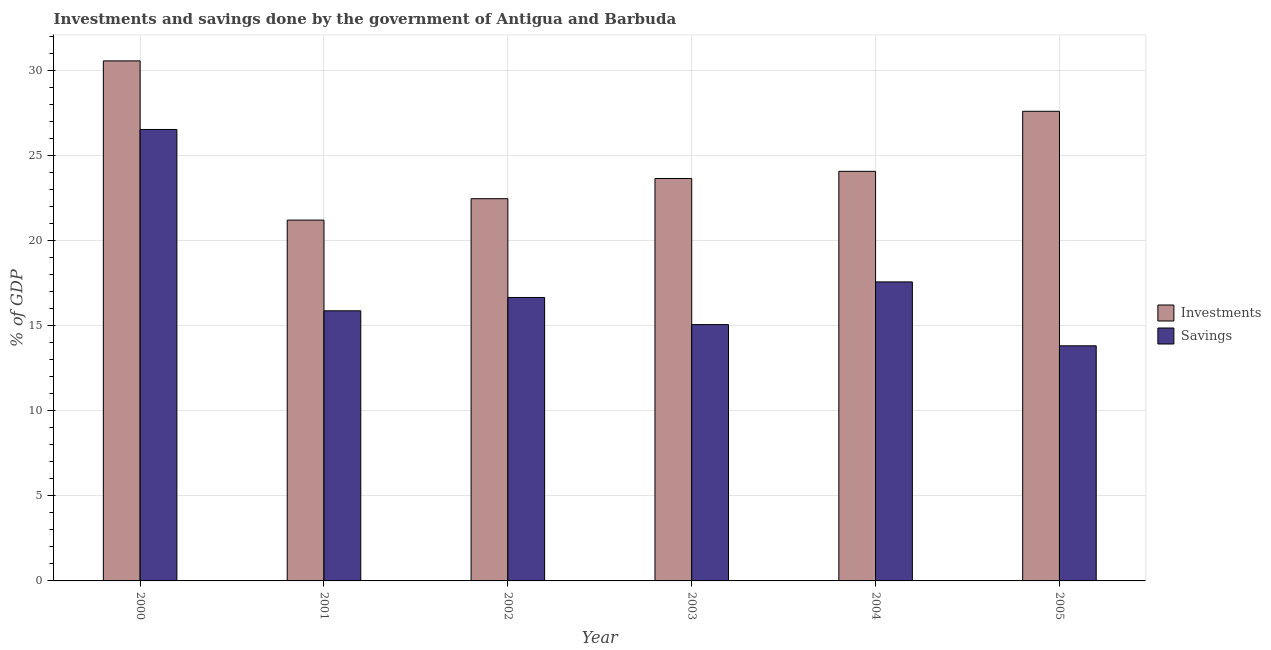Are the number of bars per tick equal to the number of legend labels?
Provide a short and direct response. Yes. Are the number of bars on each tick of the X-axis equal?
Ensure brevity in your answer.  Yes. What is the label of the 2nd group of bars from the left?
Ensure brevity in your answer.  2001. In how many cases, is the number of bars for a given year not equal to the number of legend labels?
Keep it short and to the point. 0. What is the savings of government in 2003?
Offer a very short reply. 15.06. Across all years, what is the maximum savings of government?
Offer a terse response. 26.53. Across all years, what is the minimum investments of government?
Provide a short and direct response. 21.2. In which year was the investments of government maximum?
Provide a short and direct response. 2000. In which year was the investments of government minimum?
Your answer should be compact. 2001. What is the total savings of government in the graph?
Your answer should be compact. 105.51. What is the difference between the investments of government in 2001 and that in 2002?
Your answer should be very brief. -1.26. What is the difference between the savings of government in 2005 and the investments of government in 2003?
Offer a terse response. -1.25. What is the average investments of government per year?
Offer a terse response. 24.92. In the year 2005, what is the difference between the savings of government and investments of government?
Offer a terse response. 0. In how many years, is the savings of government greater than 9 %?
Offer a terse response. 6. What is the ratio of the investments of government in 2002 to that in 2004?
Give a very brief answer. 0.93. Is the savings of government in 2001 less than that in 2003?
Provide a short and direct response. No. What is the difference between the highest and the second highest savings of government?
Provide a short and direct response. 8.96. What is the difference between the highest and the lowest investments of government?
Your answer should be compact. 9.36. What does the 1st bar from the left in 2001 represents?
Provide a short and direct response. Investments. What does the 2nd bar from the right in 2002 represents?
Your answer should be very brief. Investments. Are all the bars in the graph horizontal?
Provide a short and direct response. No. How many years are there in the graph?
Provide a short and direct response. 6. What is the difference between two consecutive major ticks on the Y-axis?
Make the answer very short. 5. Are the values on the major ticks of Y-axis written in scientific E-notation?
Offer a very short reply. No. Does the graph contain grids?
Keep it short and to the point. Yes. Where does the legend appear in the graph?
Offer a very short reply. Center right. What is the title of the graph?
Give a very brief answer. Investments and savings done by the government of Antigua and Barbuda. Does "Official aid received" appear as one of the legend labels in the graph?
Give a very brief answer. No. What is the label or title of the X-axis?
Provide a succinct answer. Year. What is the label or title of the Y-axis?
Ensure brevity in your answer.  % of GDP. What is the % of GDP in Investments in 2000?
Make the answer very short. 30.56. What is the % of GDP of Savings in 2000?
Your answer should be very brief. 26.53. What is the % of GDP of Investments in 2001?
Your answer should be compact. 21.2. What is the % of GDP in Savings in 2001?
Offer a terse response. 15.87. What is the % of GDP in Investments in 2002?
Offer a very short reply. 22.46. What is the % of GDP in Savings in 2002?
Your response must be concise. 16.66. What is the % of GDP in Investments in 2003?
Your answer should be compact. 23.65. What is the % of GDP of Savings in 2003?
Give a very brief answer. 15.06. What is the % of GDP of Investments in 2004?
Provide a succinct answer. 24.07. What is the % of GDP in Savings in 2004?
Keep it short and to the point. 17.57. What is the % of GDP in Investments in 2005?
Offer a very short reply. 27.6. What is the % of GDP of Savings in 2005?
Provide a succinct answer. 13.82. Across all years, what is the maximum % of GDP of Investments?
Provide a succinct answer. 30.56. Across all years, what is the maximum % of GDP of Savings?
Provide a short and direct response. 26.53. Across all years, what is the minimum % of GDP of Investments?
Your answer should be very brief. 21.2. Across all years, what is the minimum % of GDP in Savings?
Provide a short and direct response. 13.82. What is the total % of GDP of Investments in the graph?
Provide a short and direct response. 149.53. What is the total % of GDP in Savings in the graph?
Keep it short and to the point. 105.51. What is the difference between the % of GDP in Investments in 2000 and that in 2001?
Give a very brief answer. 9.36. What is the difference between the % of GDP of Savings in 2000 and that in 2001?
Provide a short and direct response. 10.65. What is the difference between the % of GDP in Investments in 2000 and that in 2002?
Provide a short and direct response. 8.1. What is the difference between the % of GDP of Savings in 2000 and that in 2002?
Your answer should be compact. 9.87. What is the difference between the % of GDP of Investments in 2000 and that in 2003?
Offer a terse response. 6.91. What is the difference between the % of GDP of Savings in 2000 and that in 2003?
Your answer should be compact. 11.47. What is the difference between the % of GDP of Investments in 2000 and that in 2004?
Provide a succinct answer. 6.49. What is the difference between the % of GDP in Savings in 2000 and that in 2004?
Give a very brief answer. 8.96. What is the difference between the % of GDP in Investments in 2000 and that in 2005?
Offer a terse response. 2.96. What is the difference between the % of GDP in Savings in 2000 and that in 2005?
Keep it short and to the point. 12.71. What is the difference between the % of GDP of Investments in 2001 and that in 2002?
Your response must be concise. -1.26. What is the difference between the % of GDP in Savings in 2001 and that in 2002?
Keep it short and to the point. -0.78. What is the difference between the % of GDP of Investments in 2001 and that in 2003?
Make the answer very short. -2.44. What is the difference between the % of GDP in Savings in 2001 and that in 2003?
Make the answer very short. 0.81. What is the difference between the % of GDP in Investments in 2001 and that in 2004?
Provide a succinct answer. -2.87. What is the difference between the % of GDP in Savings in 2001 and that in 2004?
Make the answer very short. -1.7. What is the difference between the % of GDP of Investments in 2001 and that in 2005?
Your answer should be compact. -6.39. What is the difference between the % of GDP of Savings in 2001 and that in 2005?
Offer a very short reply. 2.06. What is the difference between the % of GDP of Investments in 2002 and that in 2003?
Provide a short and direct response. -1.19. What is the difference between the % of GDP in Savings in 2002 and that in 2003?
Give a very brief answer. 1.59. What is the difference between the % of GDP of Investments in 2002 and that in 2004?
Your answer should be compact. -1.61. What is the difference between the % of GDP of Savings in 2002 and that in 2004?
Your answer should be compact. -0.92. What is the difference between the % of GDP in Investments in 2002 and that in 2005?
Your response must be concise. -5.14. What is the difference between the % of GDP in Savings in 2002 and that in 2005?
Offer a terse response. 2.84. What is the difference between the % of GDP in Investments in 2003 and that in 2004?
Give a very brief answer. -0.42. What is the difference between the % of GDP in Savings in 2003 and that in 2004?
Give a very brief answer. -2.51. What is the difference between the % of GDP of Investments in 2003 and that in 2005?
Offer a terse response. -3.95. What is the difference between the % of GDP in Savings in 2003 and that in 2005?
Offer a very short reply. 1.25. What is the difference between the % of GDP of Investments in 2004 and that in 2005?
Offer a terse response. -3.53. What is the difference between the % of GDP of Savings in 2004 and that in 2005?
Offer a very short reply. 3.76. What is the difference between the % of GDP in Investments in 2000 and the % of GDP in Savings in 2001?
Ensure brevity in your answer.  14.69. What is the difference between the % of GDP in Investments in 2000 and the % of GDP in Savings in 2002?
Give a very brief answer. 13.9. What is the difference between the % of GDP of Investments in 2000 and the % of GDP of Savings in 2003?
Offer a very short reply. 15.5. What is the difference between the % of GDP of Investments in 2000 and the % of GDP of Savings in 2004?
Your response must be concise. 12.99. What is the difference between the % of GDP of Investments in 2000 and the % of GDP of Savings in 2005?
Make the answer very short. 16.74. What is the difference between the % of GDP of Investments in 2001 and the % of GDP of Savings in 2002?
Give a very brief answer. 4.55. What is the difference between the % of GDP in Investments in 2001 and the % of GDP in Savings in 2003?
Your response must be concise. 6.14. What is the difference between the % of GDP in Investments in 2001 and the % of GDP in Savings in 2004?
Give a very brief answer. 3.63. What is the difference between the % of GDP of Investments in 2001 and the % of GDP of Savings in 2005?
Offer a terse response. 7.39. What is the difference between the % of GDP of Investments in 2002 and the % of GDP of Savings in 2003?
Make the answer very short. 7.4. What is the difference between the % of GDP in Investments in 2002 and the % of GDP in Savings in 2004?
Offer a terse response. 4.89. What is the difference between the % of GDP in Investments in 2002 and the % of GDP in Savings in 2005?
Offer a very short reply. 8.64. What is the difference between the % of GDP in Investments in 2003 and the % of GDP in Savings in 2004?
Your answer should be compact. 6.08. What is the difference between the % of GDP in Investments in 2003 and the % of GDP in Savings in 2005?
Offer a very short reply. 9.83. What is the difference between the % of GDP of Investments in 2004 and the % of GDP of Savings in 2005?
Your answer should be compact. 10.25. What is the average % of GDP in Investments per year?
Give a very brief answer. 24.92. What is the average % of GDP of Savings per year?
Ensure brevity in your answer.  17.58. In the year 2000, what is the difference between the % of GDP in Investments and % of GDP in Savings?
Give a very brief answer. 4.03. In the year 2001, what is the difference between the % of GDP of Investments and % of GDP of Savings?
Ensure brevity in your answer.  5.33. In the year 2002, what is the difference between the % of GDP in Investments and % of GDP in Savings?
Provide a succinct answer. 5.8. In the year 2003, what is the difference between the % of GDP of Investments and % of GDP of Savings?
Offer a terse response. 8.58. In the year 2004, what is the difference between the % of GDP in Investments and % of GDP in Savings?
Provide a succinct answer. 6.5. In the year 2005, what is the difference between the % of GDP in Investments and % of GDP in Savings?
Offer a very short reply. 13.78. What is the ratio of the % of GDP of Investments in 2000 to that in 2001?
Your response must be concise. 1.44. What is the ratio of the % of GDP in Savings in 2000 to that in 2001?
Provide a short and direct response. 1.67. What is the ratio of the % of GDP of Investments in 2000 to that in 2002?
Give a very brief answer. 1.36. What is the ratio of the % of GDP of Savings in 2000 to that in 2002?
Offer a very short reply. 1.59. What is the ratio of the % of GDP of Investments in 2000 to that in 2003?
Provide a succinct answer. 1.29. What is the ratio of the % of GDP of Savings in 2000 to that in 2003?
Offer a very short reply. 1.76. What is the ratio of the % of GDP of Investments in 2000 to that in 2004?
Make the answer very short. 1.27. What is the ratio of the % of GDP in Savings in 2000 to that in 2004?
Ensure brevity in your answer.  1.51. What is the ratio of the % of GDP of Investments in 2000 to that in 2005?
Offer a terse response. 1.11. What is the ratio of the % of GDP of Savings in 2000 to that in 2005?
Your answer should be compact. 1.92. What is the ratio of the % of GDP of Investments in 2001 to that in 2002?
Ensure brevity in your answer.  0.94. What is the ratio of the % of GDP of Savings in 2001 to that in 2002?
Ensure brevity in your answer.  0.95. What is the ratio of the % of GDP in Investments in 2001 to that in 2003?
Your response must be concise. 0.9. What is the ratio of the % of GDP of Savings in 2001 to that in 2003?
Offer a terse response. 1.05. What is the ratio of the % of GDP of Investments in 2001 to that in 2004?
Ensure brevity in your answer.  0.88. What is the ratio of the % of GDP of Savings in 2001 to that in 2004?
Offer a very short reply. 0.9. What is the ratio of the % of GDP of Investments in 2001 to that in 2005?
Provide a short and direct response. 0.77. What is the ratio of the % of GDP in Savings in 2001 to that in 2005?
Keep it short and to the point. 1.15. What is the ratio of the % of GDP in Investments in 2002 to that in 2003?
Keep it short and to the point. 0.95. What is the ratio of the % of GDP of Savings in 2002 to that in 2003?
Make the answer very short. 1.11. What is the ratio of the % of GDP in Investments in 2002 to that in 2004?
Make the answer very short. 0.93. What is the ratio of the % of GDP in Savings in 2002 to that in 2004?
Keep it short and to the point. 0.95. What is the ratio of the % of GDP of Investments in 2002 to that in 2005?
Offer a very short reply. 0.81. What is the ratio of the % of GDP of Savings in 2002 to that in 2005?
Ensure brevity in your answer.  1.21. What is the ratio of the % of GDP of Investments in 2003 to that in 2004?
Provide a short and direct response. 0.98. What is the ratio of the % of GDP of Savings in 2003 to that in 2004?
Your answer should be compact. 0.86. What is the ratio of the % of GDP of Investments in 2003 to that in 2005?
Provide a succinct answer. 0.86. What is the ratio of the % of GDP of Savings in 2003 to that in 2005?
Offer a terse response. 1.09. What is the ratio of the % of GDP in Investments in 2004 to that in 2005?
Your answer should be very brief. 0.87. What is the ratio of the % of GDP of Savings in 2004 to that in 2005?
Ensure brevity in your answer.  1.27. What is the difference between the highest and the second highest % of GDP of Investments?
Ensure brevity in your answer.  2.96. What is the difference between the highest and the second highest % of GDP in Savings?
Ensure brevity in your answer.  8.96. What is the difference between the highest and the lowest % of GDP in Investments?
Your answer should be very brief. 9.36. What is the difference between the highest and the lowest % of GDP in Savings?
Give a very brief answer. 12.71. 